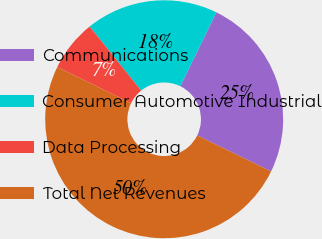<chart> <loc_0><loc_0><loc_500><loc_500><pie_chart><fcel>Communications<fcel>Consumer Automotive Industrial<fcel>Data Processing<fcel>Total Net Revenues<nl><fcel>25.0%<fcel>18.0%<fcel>7.0%<fcel>50.0%<nl></chart> 